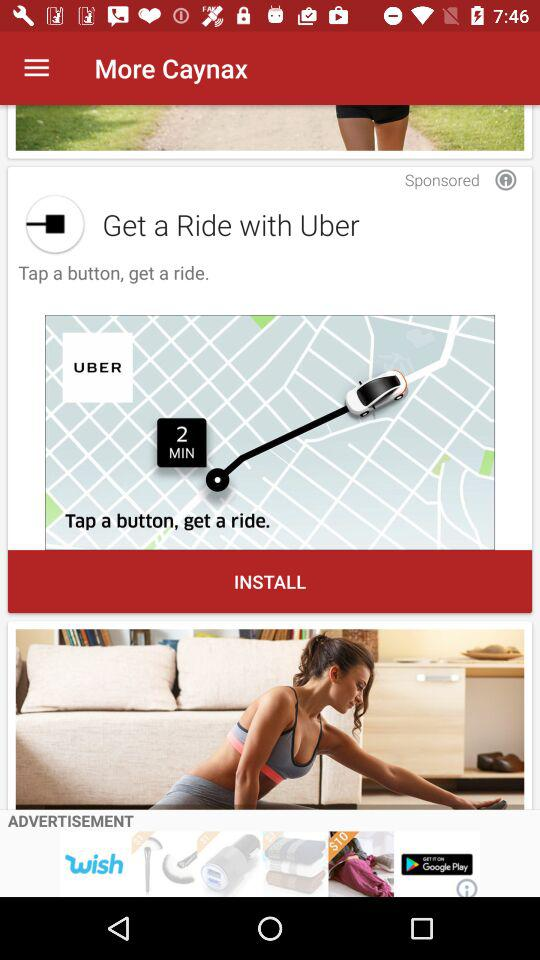What is the name of the application? The application name is "Uber". 